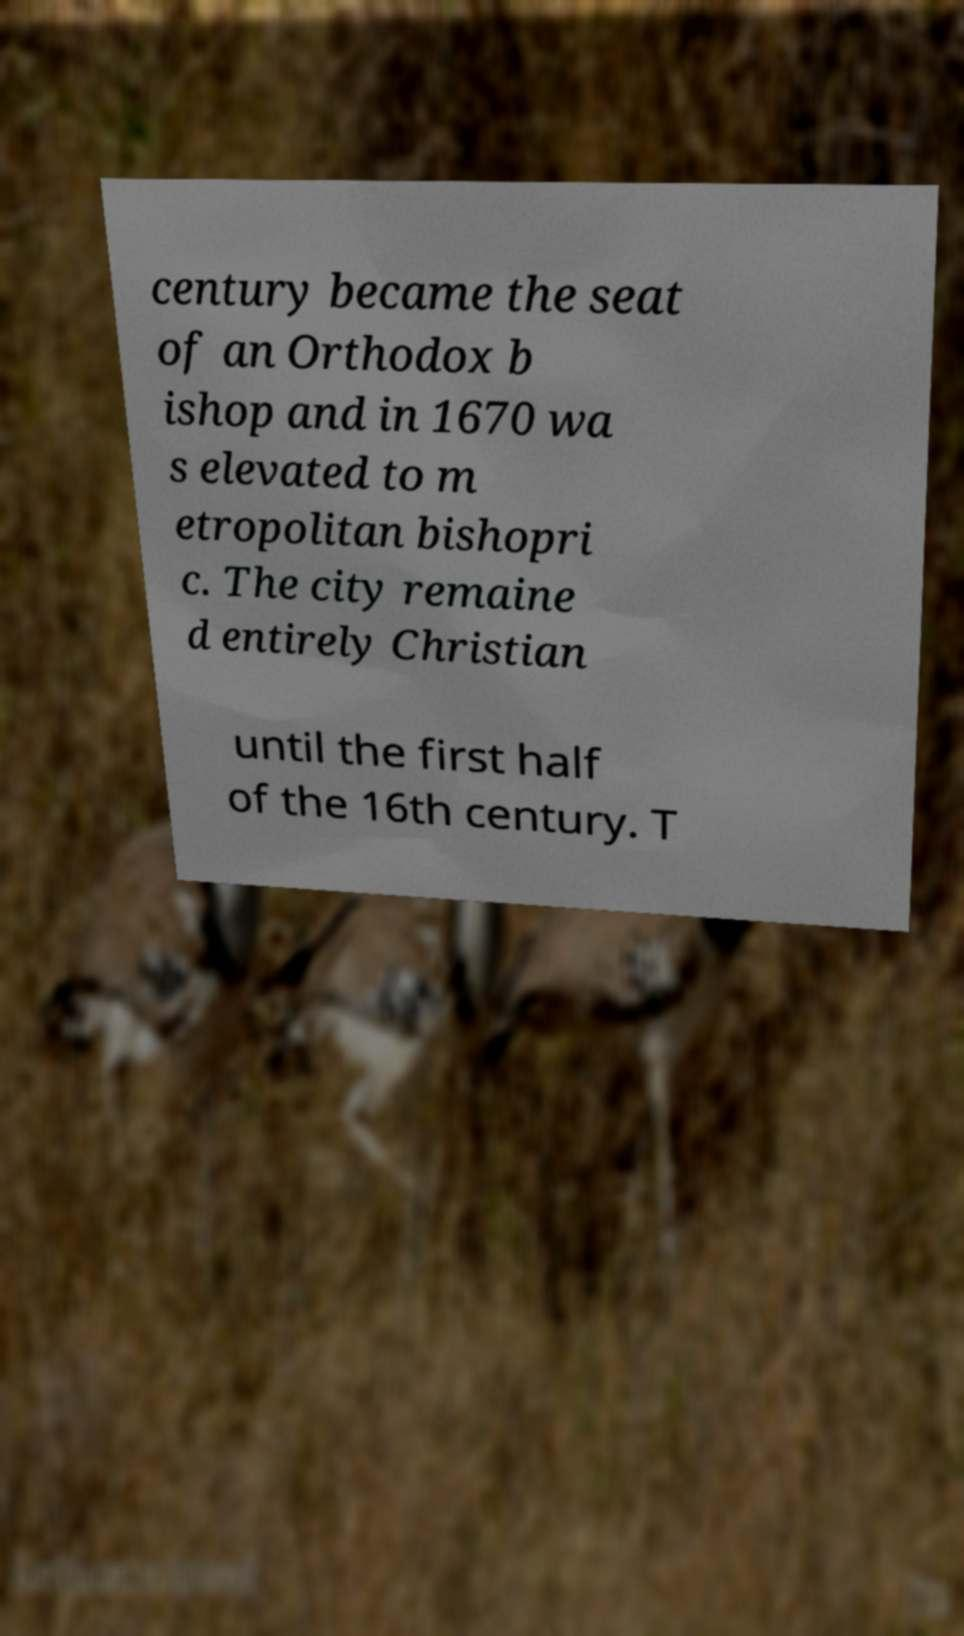Can you read and provide the text displayed in the image?This photo seems to have some interesting text. Can you extract and type it out for me? century became the seat of an Orthodox b ishop and in 1670 wa s elevated to m etropolitan bishopri c. The city remaine d entirely Christian until the first half of the 16th century. T 